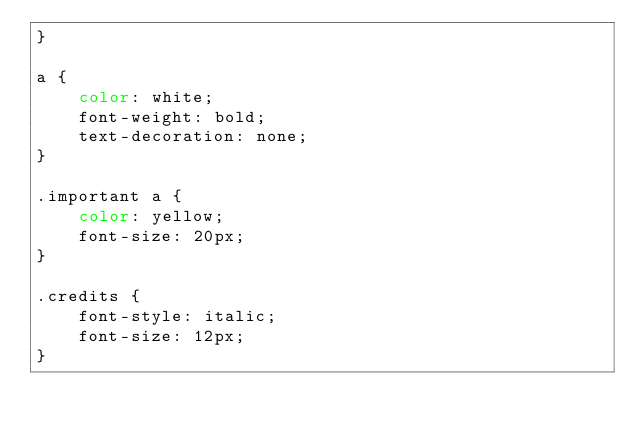Convert code to text. <code><loc_0><loc_0><loc_500><loc_500><_CSS_>}

a {
    color: white;
    font-weight: bold;
    text-decoration: none;
}

.important a {
    color: yellow;
    font-size: 20px;
}

.credits {
    font-style: italic;
    font-size: 12px;
}</code> 